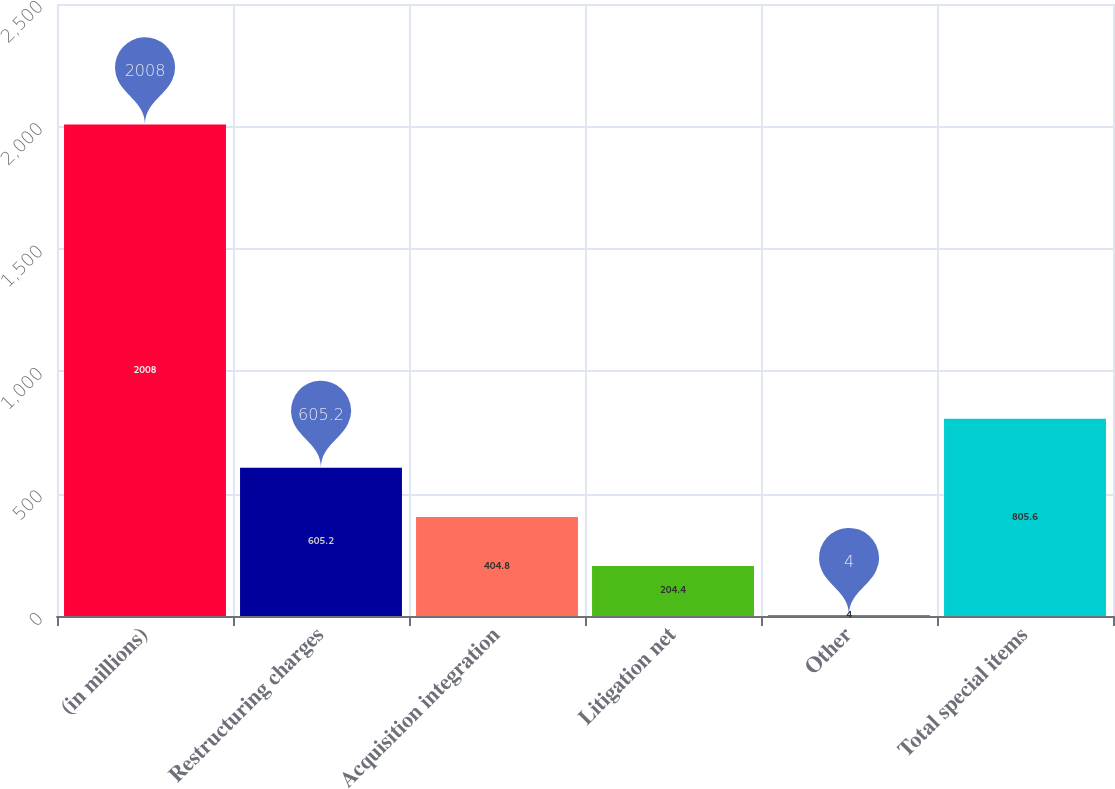Convert chart to OTSL. <chart><loc_0><loc_0><loc_500><loc_500><bar_chart><fcel>(in millions)<fcel>Restructuring charges<fcel>Acquisition integration<fcel>Litigation net<fcel>Other<fcel>Total special items<nl><fcel>2008<fcel>605.2<fcel>404.8<fcel>204.4<fcel>4<fcel>805.6<nl></chart> 